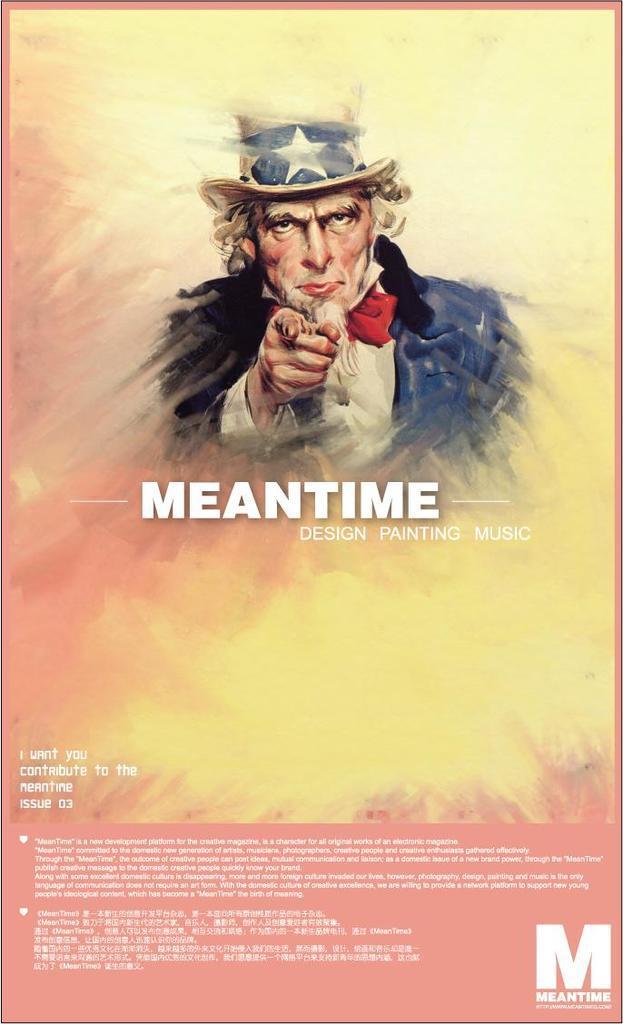Describe this image in one or two sentences. In this image I can see a poster which is pink and yellow in color and I can see a person wearing red, black, white and blue colored dress and white and blue colored hat on the poster. 